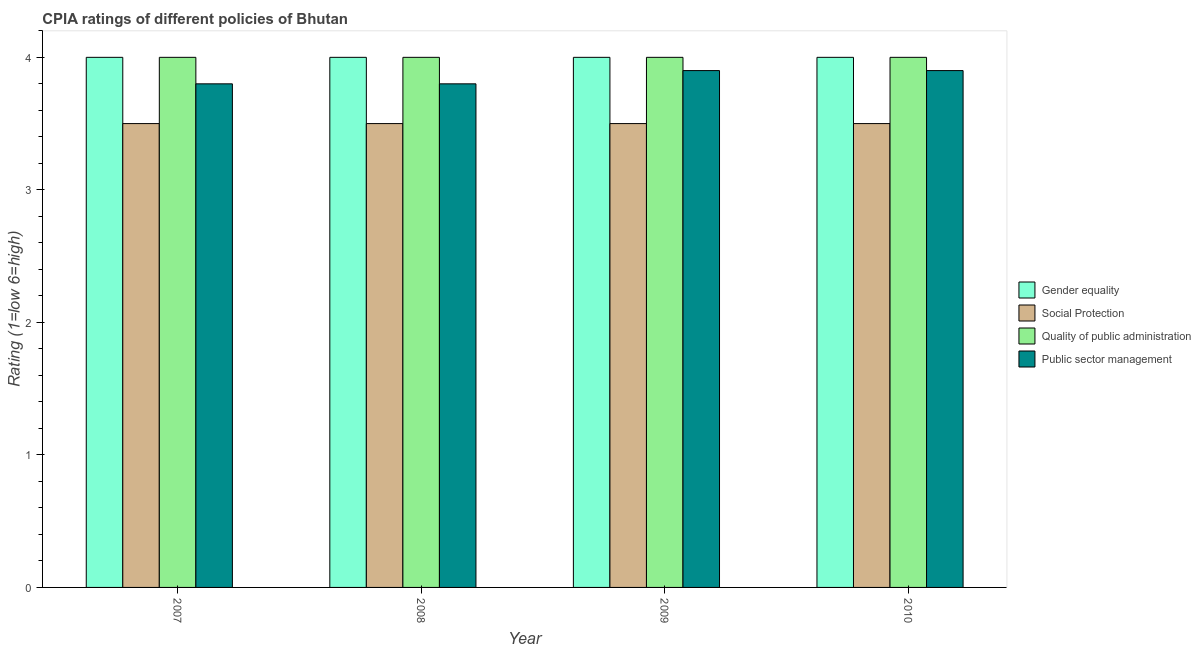How many different coloured bars are there?
Give a very brief answer. 4. How many groups of bars are there?
Give a very brief answer. 4. Are the number of bars on each tick of the X-axis equal?
Provide a succinct answer. Yes. How many bars are there on the 2nd tick from the left?
Keep it short and to the point. 4. How many bars are there on the 1st tick from the right?
Ensure brevity in your answer.  4. What is the label of the 4th group of bars from the left?
Keep it short and to the point. 2010. In how many cases, is the number of bars for a given year not equal to the number of legend labels?
Your answer should be very brief. 0. What is the cpia rating of quality of public administration in 2007?
Your response must be concise. 4. Across all years, what is the maximum cpia rating of quality of public administration?
Your response must be concise. 4. Across all years, what is the minimum cpia rating of quality of public administration?
Your answer should be very brief. 4. In which year was the cpia rating of gender equality maximum?
Make the answer very short. 2007. In which year was the cpia rating of quality of public administration minimum?
Offer a very short reply. 2007. What is the difference between the cpia rating of gender equality in 2007 and that in 2009?
Offer a very short reply. 0. What is the difference between the cpia rating of public sector management in 2008 and the cpia rating of social protection in 2007?
Give a very brief answer. 0. What is the average cpia rating of public sector management per year?
Ensure brevity in your answer.  3.85. In the year 2009, what is the difference between the cpia rating of quality of public administration and cpia rating of public sector management?
Offer a very short reply. 0. Is the cpia rating of gender equality in 2007 less than that in 2009?
Your answer should be compact. No. Is the difference between the cpia rating of quality of public administration in 2007 and 2009 greater than the difference between the cpia rating of public sector management in 2007 and 2009?
Keep it short and to the point. No. What is the difference between the highest and the second highest cpia rating of public sector management?
Your answer should be very brief. 0. In how many years, is the cpia rating of gender equality greater than the average cpia rating of gender equality taken over all years?
Ensure brevity in your answer.  0. What does the 2nd bar from the left in 2009 represents?
Give a very brief answer. Social Protection. What does the 1st bar from the right in 2008 represents?
Your response must be concise. Public sector management. How many years are there in the graph?
Your response must be concise. 4. Where does the legend appear in the graph?
Give a very brief answer. Center right. How many legend labels are there?
Offer a very short reply. 4. How are the legend labels stacked?
Keep it short and to the point. Vertical. What is the title of the graph?
Your response must be concise. CPIA ratings of different policies of Bhutan. What is the label or title of the X-axis?
Your answer should be compact. Year. What is the label or title of the Y-axis?
Ensure brevity in your answer.  Rating (1=low 6=high). What is the Rating (1=low 6=high) in Gender equality in 2007?
Keep it short and to the point. 4. What is the Rating (1=low 6=high) of Gender equality in 2008?
Offer a very short reply. 4. What is the Rating (1=low 6=high) of Social Protection in 2008?
Ensure brevity in your answer.  3.5. What is the Rating (1=low 6=high) of Quality of public administration in 2008?
Ensure brevity in your answer.  4. What is the Rating (1=low 6=high) in Public sector management in 2008?
Provide a short and direct response. 3.8. What is the Rating (1=low 6=high) in Social Protection in 2009?
Give a very brief answer. 3.5. What is the Rating (1=low 6=high) in Quality of public administration in 2009?
Give a very brief answer. 4. What is the Rating (1=low 6=high) in Gender equality in 2010?
Your answer should be compact. 4. What is the Rating (1=low 6=high) of Social Protection in 2010?
Provide a succinct answer. 3.5. What is the Rating (1=low 6=high) in Quality of public administration in 2010?
Provide a short and direct response. 4. What is the Rating (1=low 6=high) in Public sector management in 2010?
Provide a short and direct response. 3.9. Across all years, what is the maximum Rating (1=low 6=high) in Gender equality?
Make the answer very short. 4. Across all years, what is the maximum Rating (1=low 6=high) of Public sector management?
Ensure brevity in your answer.  3.9. Across all years, what is the minimum Rating (1=low 6=high) in Gender equality?
Keep it short and to the point. 4. Across all years, what is the minimum Rating (1=low 6=high) in Quality of public administration?
Your answer should be compact. 4. Across all years, what is the minimum Rating (1=low 6=high) of Public sector management?
Your answer should be very brief. 3.8. What is the total Rating (1=low 6=high) in Public sector management in the graph?
Your answer should be very brief. 15.4. What is the difference between the Rating (1=low 6=high) in Gender equality in 2007 and that in 2008?
Keep it short and to the point. 0. What is the difference between the Rating (1=low 6=high) in Social Protection in 2007 and that in 2008?
Provide a short and direct response. 0. What is the difference between the Rating (1=low 6=high) in Quality of public administration in 2007 and that in 2008?
Offer a terse response. 0. What is the difference between the Rating (1=low 6=high) of Public sector management in 2007 and that in 2008?
Provide a short and direct response. 0. What is the difference between the Rating (1=low 6=high) of Social Protection in 2007 and that in 2009?
Your answer should be compact. 0. What is the difference between the Rating (1=low 6=high) of Quality of public administration in 2007 and that in 2009?
Provide a short and direct response. 0. What is the difference between the Rating (1=low 6=high) in Gender equality in 2007 and that in 2010?
Your answer should be compact. 0. What is the difference between the Rating (1=low 6=high) of Quality of public administration in 2007 and that in 2010?
Provide a short and direct response. 0. What is the difference between the Rating (1=low 6=high) in Public sector management in 2007 and that in 2010?
Your answer should be very brief. -0.1. What is the difference between the Rating (1=low 6=high) in Gender equality in 2008 and that in 2009?
Make the answer very short. 0. What is the difference between the Rating (1=low 6=high) of Social Protection in 2008 and that in 2010?
Make the answer very short. 0. What is the difference between the Rating (1=low 6=high) in Public sector management in 2008 and that in 2010?
Provide a short and direct response. -0.1. What is the difference between the Rating (1=low 6=high) in Gender equality in 2009 and that in 2010?
Ensure brevity in your answer.  0. What is the difference between the Rating (1=low 6=high) of Social Protection in 2009 and that in 2010?
Provide a short and direct response. 0. What is the difference between the Rating (1=low 6=high) in Quality of public administration in 2009 and that in 2010?
Give a very brief answer. 0. What is the difference between the Rating (1=low 6=high) in Public sector management in 2009 and that in 2010?
Your answer should be very brief. 0. What is the difference between the Rating (1=low 6=high) of Gender equality in 2007 and the Rating (1=low 6=high) of Social Protection in 2008?
Your answer should be very brief. 0.5. What is the difference between the Rating (1=low 6=high) of Social Protection in 2007 and the Rating (1=low 6=high) of Public sector management in 2008?
Provide a short and direct response. -0.3. What is the difference between the Rating (1=low 6=high) of Quality of public administration in 2007 and the Rating (1=low 6=high) of Public sector management in 2008?
Your response must be concise. 0.2. What is the difference between the Rating (1=low 6=high) in Gender equality in 2007 and the Rating (1=low 6=high) in Quality of public administration in 2009?
Provide a short and direct response. 0. What is the difference between the Rating (1=low 6=high) of Gender equality in 2007 and the Rating (1=low 6=high) of Public sector management in 2009?
Offer a very short reply. 0.1. What is the difference between the Rating (1=low 6=high) of Social Protection in 2007 and the Rating (1=low 6=high) of Public sector management in 2009?
Offer a terse response. -0.4. What is the difference between the Rating (1=low 6=high) in Quality of public administration in 2007 and the Rating (1=low 6=high) in Public sector management in 2009?
Make the answer very short. 0.1. What is the difference between the Rating (1=low 6=high) in Gender equality in 2007 and the Rating (1=low 6=high) in Social Protection in 2010?
Give a very brief answer. 0.5. What is the difference between the Rating (1=low 6=high) of Gender equality in 2007 and the Rating (1=low 6=high) of Public sector management in 2010?
Your answer should be very brief. 0.1. What is the difference between the Rating (1=low 6=high) in Social Protection in 2007 and the Rating (1=low 6=high) in Quality of public administration in 2010?
Give a very brief answer. -0.5. What is the difference between the Rating (1=low 6=high) in Social Protection in 2007 and the Rating (1=low 6=high) in Public sector management in 2010?
Your answer should be very brief. -0.4. What is the difference between the Rating (1=low 6=high) of Gender equality in 2008 and the Rating (1=low 6=high) of Social Protection in 2009?
Offer a terse response. 0.5. What is the difference between the Rating (1=low 6=high) in Gender equality in 2008 and the Rating (1=low 6=high) in Quality of public administration in 2009?
Give a very brief answer. 0. What is the difference between the Rating (1=low 6=high) of Gender equality in 2008 and the Rating (1=low 6=high) of Public sector management in 2009?
Make the answer very short. 0.1. What is the difference between the Rating (1=low 6=high) in Social Protection in 2008 and the Rating (1=low 6=high) in Public sector management in 2009?
Make the answer very short. -0.4. What is the difference between the Rating (1=low 6=high) in Gender equality in 2008 and the Rating (1=low 6=high) in Social Protection in 2010?
Offer a very short reply. 0.5. What is the difference between the Rating (1=low 6=high) of Gender equality in 2008 and the Rating (1=low 6=high) of Public sector management in 2010?
Your answer should be very brief. 0.1. What is the difference between the Rating (1=low 6=high) of Social Protection in 2008 and the Rating (1=low 6=high) of Public sector management in 2010?
Provide a short and direct response. -0.4. What is the difference between the Rating (1=low 6=high) in Gender equality in 2009 and the Rating (1=low 6=high) in Public sector management in 2010?
Keep it short and to the point. 0.1. What is the difference between the Rating (1=low 6=high) of Social Protection in 2009 and the Rating (1=low 6=high) of Public sector management in 2010?
Make the answer very short. -0.4. What is the average Rating (1=low 6=high) in Gender equality per year?
Offer a terse response. 4. What is the average Rating (1=low 6=high) of Quality of public administration per year?
Offer a terse response. 4. What is the average Rating (1=low 6=high) of Public sector management per year?
Your answer should be very brief. 3.85. In the year 2007, what is the difference between the Rating (1=low 6=high) in Gender equality and Rating (1=low 6=high) in Social Protection?
Make the answer very short. 0.5. In the year 2007, what is the difference between the Rating (1=low 6=high) in Gender equality and Rating (1=low 6=high) in Public sector management?
Give a very brief answer. 0.2. In the year 2007, what is the difference between the Rating (1=low 6=high) of Quality of public administration and Rating (1=low 6=high) of Public sector management?
Your answer should be compact. 0.2. In the year 2008, what is the difference between the Rating (1=low 6=high) in Gender equality and Rating (1=low 6=high) in Social Protection?
Offer a terse response. 0.5. In the year 2008, what is the difference between the Rating (1=low 6=high) of Social Protection and Rating (1=low 6=high) of Quality of public administration?
Give a very brief answer. -0.5. In the year 2008, what is the difference between the Rating (1=low 6=high) of Quality of public administration and Rating (1=low 6=high) of Public sector management?
Your response must be concise. 0.2. In the year 2009, what is the difference between the Rating (1=low 6=high) in Gender equality and Rating (1=low 6=high) in Social Protection?
Offer a terse response. 0.5. In the year 2009, what is the difference between the Rating (1=low 6=high) in Gender equality and Rating (1=low 6=high) in Public sector management?
Offer a terse response. 0.1. In the year 2010, what is the difference between the Rating (1=low 6=high) in Social Protection and Rating (1=low 6=high) in Quality of public administration?
Give a very brief answer. -0.5. In the year 2010, what is the difference between the Rating (1=low 6=high) of Social Protection and Rating (1=low 6=high) of Public sector management?
Ensure brevity in your answer.  -0.4. What is the ratio of the Rating (1=low 6=high) of Social Protection in 2007 to that in 2008?
Offer a terse response. 1. What is the ratio of the Rating (1=low 6=high) of Public sector management in 2007 to that in 2008?
Provide a short and direct response. 1. What is the ratio of the Rating (1=low 6=high) of Gender equality in 2007 to that in 2009?
Make the answer very short. 1. What is the ratio of the Rating (1=low 6=high) of Social Protection in 2007 to that in 2009?
Give a very brief answer. 1. What is the ratio of the Rating (1=low 6=high) of Quality of public administration in 2007 to that in 2009?
Provide a succinct answer. 1. What is the ratio of the Rating (1=low 6=high) of Public sector management in 2007 to that in 2009?
Offer a very short reply. 0.97. What is the ratio of the Rating (1=low 6=high) in Quality of public administration in 2007 to that in 2010?
Make the answer very short. 1. What is the ratio of the Rating (1=low 6=high) in Public sector management in 2007 to that in 2010?
Offer a terse response. 0.97. What is the ratio of the Rating (1=low 6=high) of Gender equality in 2008 to that in 2009?
Offer a very short reply. 1. What is the ratio of the Rating (1=low 6=high) in Public sector management in 2008 to that in 2009?
Your answer should be very brief. 0.97. What is the ratio of the Rating (1=low 6=high) in Gender equality in 2008 to that in 2010?
Give a very brief answer. 1. What is the ratio of the Rating (1=low 6=high) in Social Protection in 2008 to that in 2010?
Your response must be concise. 1. What is the ratio of the Rating (1=low 6=high) of Public sector management in 2008 to that in 2010?
Offer a terse response. 0.97. What is the ratio of the Rating (1=low 6=high) in Gender equality in 2009 to that in 2010?
Keep it short and to the point. 1. What is the ratio of the Rating (1=low 6=high) of Public sector management in 2009 to that in 2010?
Offer a terse response. 1. What is the difference between the highest and the second highest Rating (1=low 6=high) of Gender equality?
Keep it short and to the point. 0. What is the difference between the highest and the second highest Rating (1=low 6=high) of Quality of public administration?
Ensure brevity in your answer.  0. 